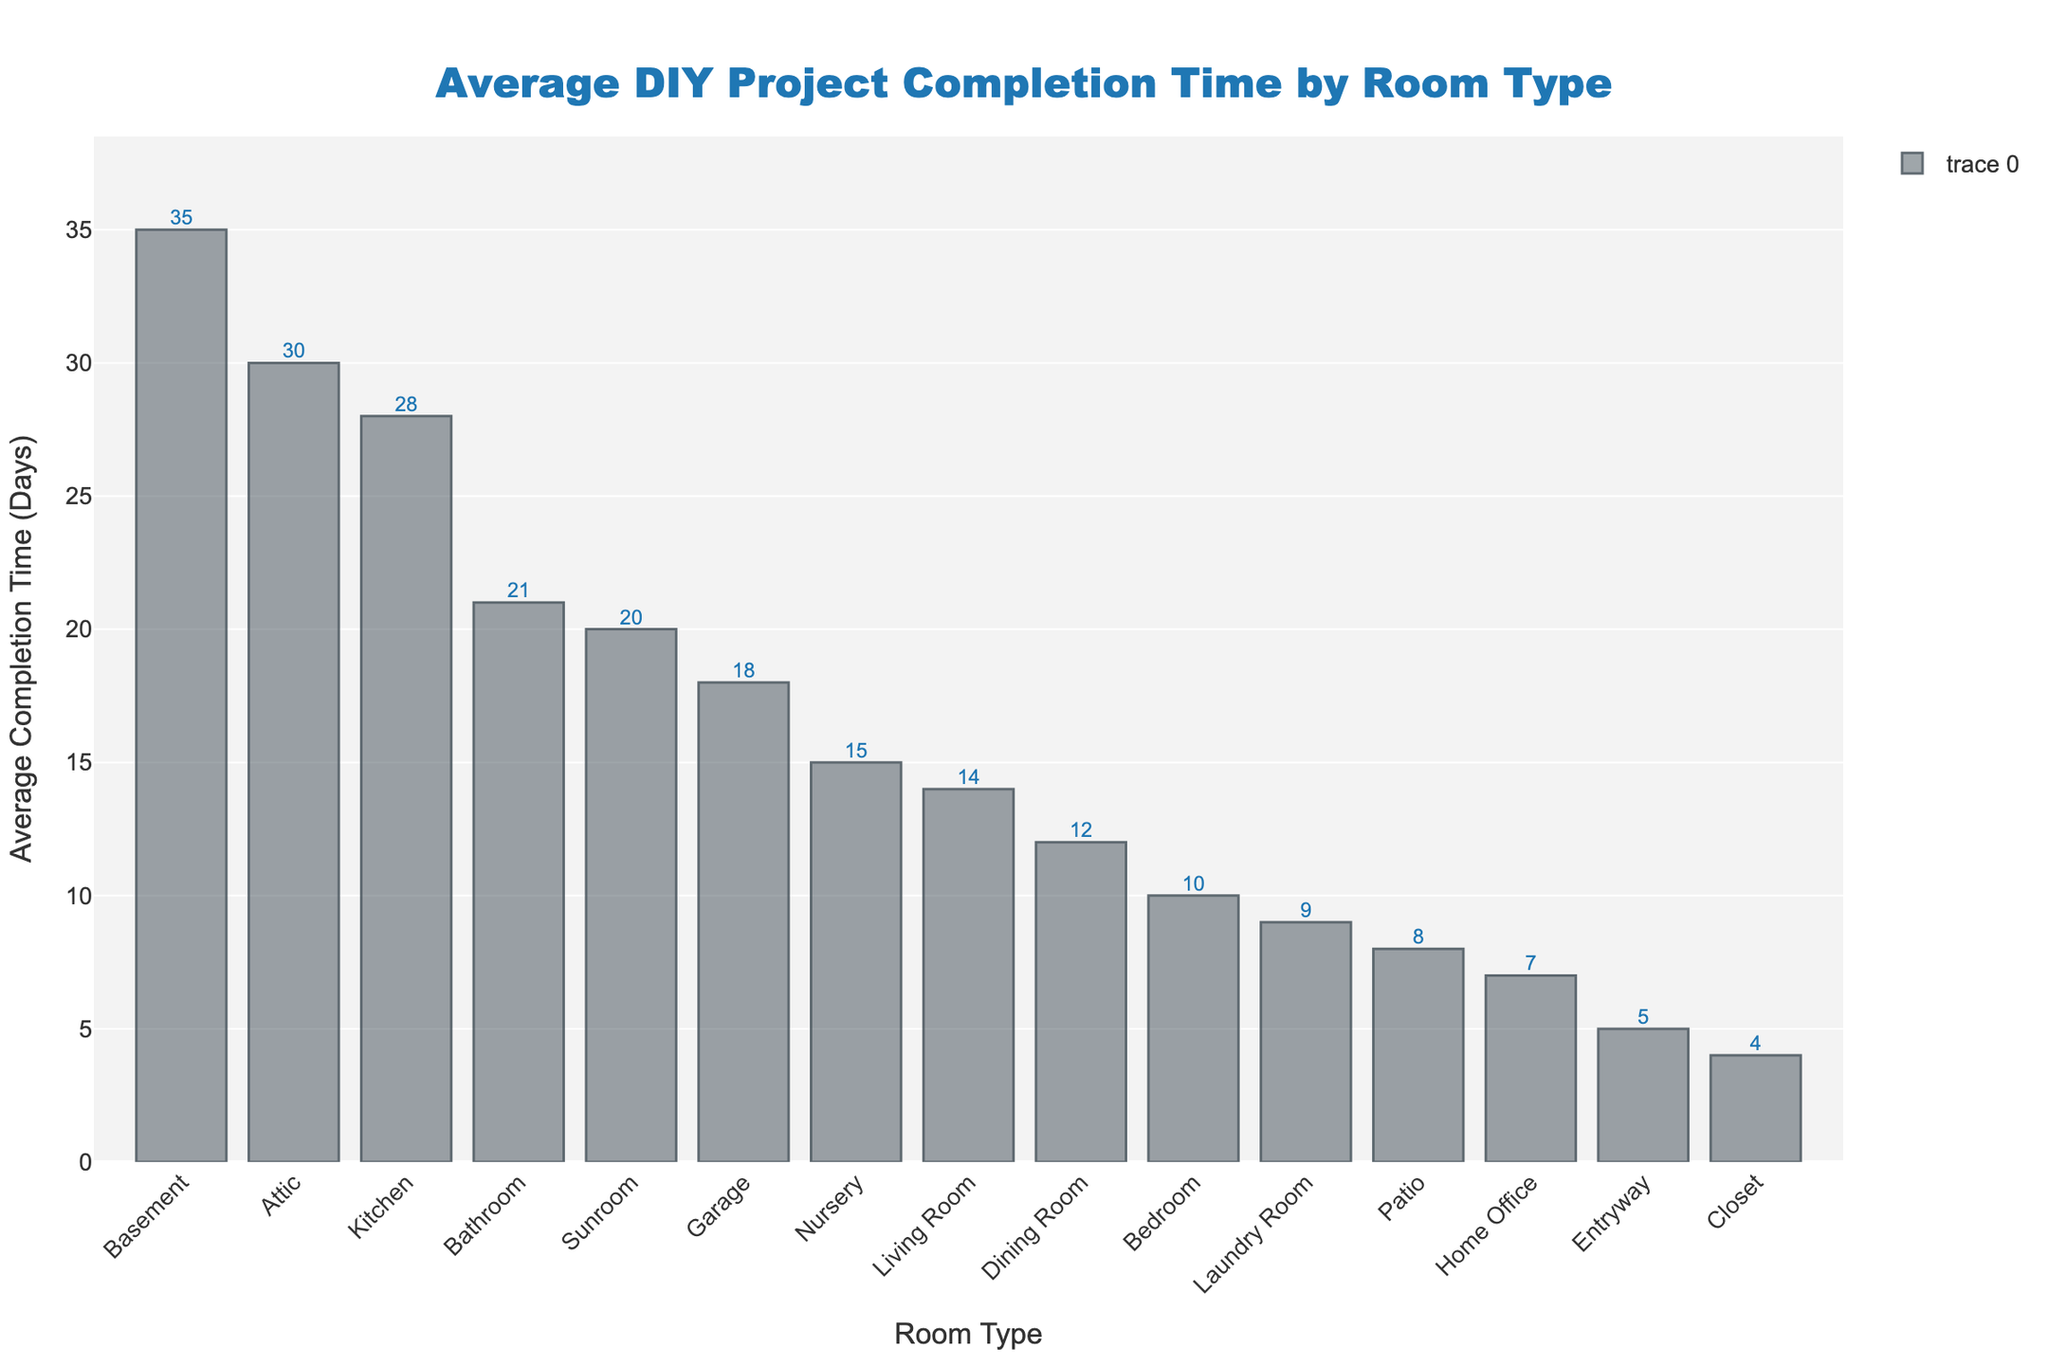Which room type takes the longest average time to complete a DIY project? By examining the heights of the bars, the "Basement" has the tallest bar, indicating it takes the longest average time to complete a DIY project, which is 35 days.
Answer: Basement Which room type has the shortest average completion time? By looking at the shorter bars, the "Closet" has the shortest average completion time at 4 days.
Answer: Closet What is the difference in average completion time between the Basement and the Kitchen? The average time for the Basement is 35 days and for the Kitchen is 28 days, so the difference is 35 - 28 = 7 days.
Answer: 7 days How many more days does it take to complete a Kitchen project compared to a Living Room project? The average time for the Kitchen is 28 days and for the Living Room is 14 days, so it takes 28 - 14 = 14 more days.
Answer: 14 days What is the average completion time for the Bathroom, Bedroom, and Home Office combined? The average times are 21 days for the Bathroom, 10 days for the Bedroom, and 7 days for the Home Office. The combined average is (21 + 10 + 7) / 3 = 12.67 days.
Answer: 12.67 days Which room type has a median average completion time, and what is it? To find the median, list the completion times in ascending order: 4, 5, 7, 8, 9, 10, 12, 14, 15, 18, 20, 21, 28, 30, 35. The median is the 8th value in this list, so the median average completion time is for the Living Room at 14 days.
Answer: Living Room, 14 days Are there more rooms with an average completion time greater than 20 days or less than or equal to 20 days? Count the number of rooms for both conditions. Greater than 20 days: Kitchen, Attic, Basement (3 rooms). Less than or equal to 20 days: (Living Room, Bathroom, Bedroom, Home Office, Dining Room, Entryway, Laundry Room, Garage, Nursery, Sunroom, Patio, Closet - 12 rooms). So, more rooms have an average completion time of less than or equal to 20 days.
Answer: Less than or equal to 20 days Which two room types have almost similar average completion times, and what are their values? By visually comparing the height of the bars, the Sunroom and the Bathroom have similar average completion times, which are both very close to 20 and 21 days respectively.
Answer: Sunroom (20 days), Bathroom (21 days) Is the average completion time for a Laundry Room project closer to that of a Bedroom or a Home Office? The average times are 9 days for the Laundry Room, 10 days for the Bedroom, and 7 days for the Home Office. The difference between Laundry Room and Bedroom is 1 day; Laundry Room and Home Office is 2 days. Therefore, Laundry Room is closer to Bedroom completion time.
Answer: Bedroom 